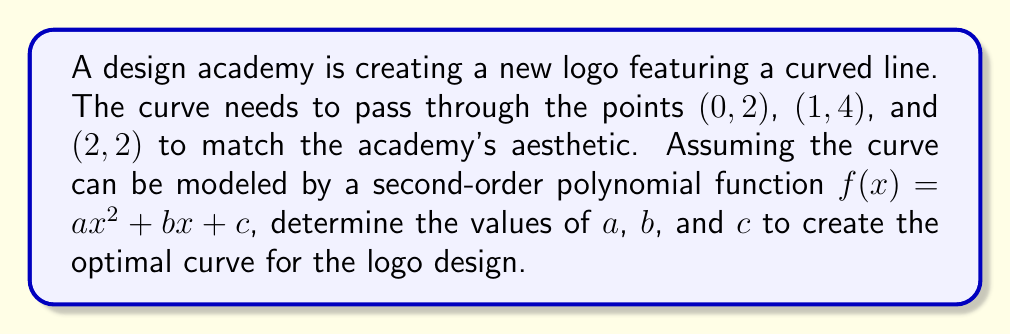Teach me how to tackle this problem. To solve this problem, we'll use the given information to set up a system of equations and solve for $a$, $b$, and $c$.

1. Set up the equations:
   Given that the curve passes through (0, 2), (1, 4), and (2, 2), we can create three equations:
   
   $f(0) = a(0)^2 + b(0) + c = 2$
   $f(1) = a(1)^2 + b(1) + c = 4$
   $f(2) = a(2)^2 + b(2) + c = 2$

2. Simplify the equations:
   
   $c = 2$
   $a + b + c = 4$
   $4a + 2b + c = 2$

3. Substitute $c = 2$ into the other equations:
   
   $a + b = 2$
   $4a + 2b = 0$

4. Solve the system of equations:
   Multiply the first equation by 2:
   $2a + 2b = 4$
   
   Subtract this from the second equation:
   $2a = -4$
   $a = -2$
   
   Substitute $a = -2$ into $a + b = 2$:
   $-2 + b = 2$
   $b = 4$

5. Verify the solution:
   $a = -2$, $b = 4$, $c = 2$
   
   Check if $f(x) = -2x^2 + 4x + 2$ passes through all three points:
   $f(0) = -2(0)^2 + 4(0) + 2 = 2$
   $f(1) = -2(1)^2 + 4(1) + 2 = 4$
   $f(2) = -2(2)^2 + 4(2) + 2 = 2$

Therefore, the optimal curve for the logo design can be represented by the function $f(x) = -2x^2 + 4x + 2$.
Answer: $f(x) = -2x^2 + 4x + 2$, where $a = -2$, $b = 4$, and $c = 2$. 